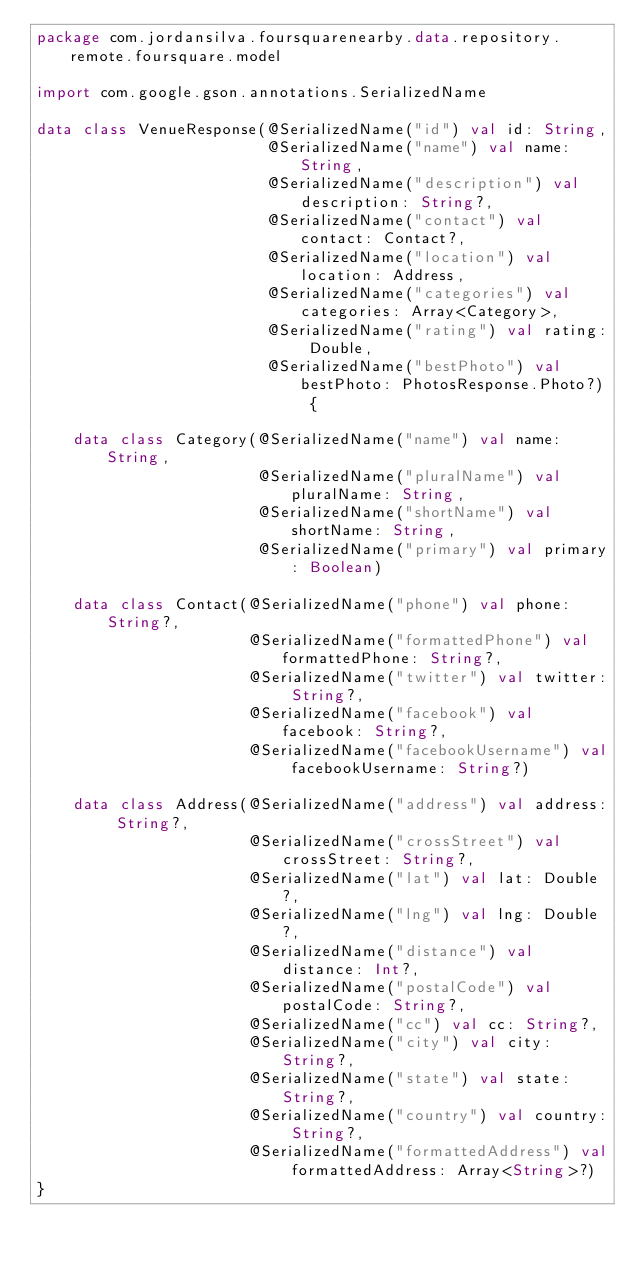Convert code to text. <code><loc_0><loc_0><loc_500><loc_500><_Kotlin_>package com.jordansilva.foursquarenearby.data.repository.remote.foursquare.model

import com.google.gson.annotations.SerializedName

data class VenueResponse(@SerializedName("id") val id: String,
                         @SerializedName("name") val name: String,
                         @SerializedName("description") val description: String?,
                         @SerializedName("contact") val contact: Contact?,
                         @SerializedName("location") val location: Address,
                         @SerializedName("categories") val categories: Array<Category>,
                         @SerializedName("rating") val rating: Double,
                         @SerializedName("bestPhoto") val bestPhoto: PhotosResponse.Photo?) {

    data class Category(@SerializedName("name") val name: String,
                        @SerializedName("pluralName") val pluralName: String,
                        @SerializedName("shortName") val shortName: String,
                        @SerializedName("primary") val primary: Boolean)

    data class Contact(@SerializedName("phone") val phone: String?,
                       @SerializedName("formattedPhone") val formattedPhone: String?,
                       @SerializedName("twitter") val twitter: String?,
                       @SerializedName("facebook") val facebook: String?,
                       @SerializedName("facebookUsername") val facebookUsername: String?)

    data class Address(@SerializedName("address") val address: String?,
                       @SerializedName("crossStreet") val crossStreet: String?,
                       @SerializedName("lat") val lat: Double?,
                       @SerializedName("lng") val lng: Double?,
                       @SerializedName("distance") val distance: Int?,
                       @SerializedName("postalCode") val postalCode: String?,
                       @SerializedName("cc") val cc: String?,
                       @SerializedName("city") val city: String?,
                       @SerializedName("state") val state: String?,
                       @SerializedName("country") val country: String?,
                       @SerializedName("formattedAddress") val formattedAddress: Array<String>?)
}</code> 